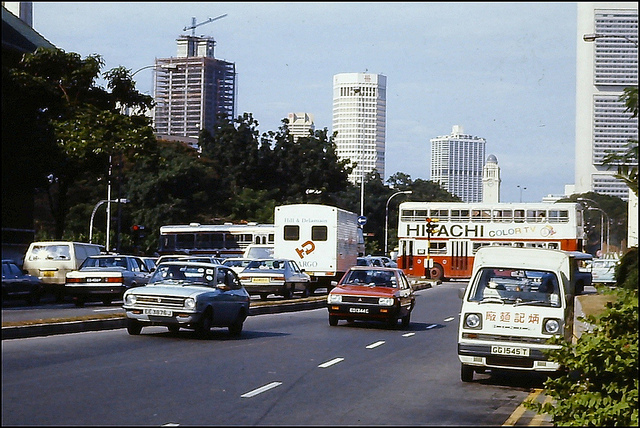How many trucks can you see? In the scene captured by the image, there are a total of three trucks visible, each varying in size and likely serving different transportation purposes. 